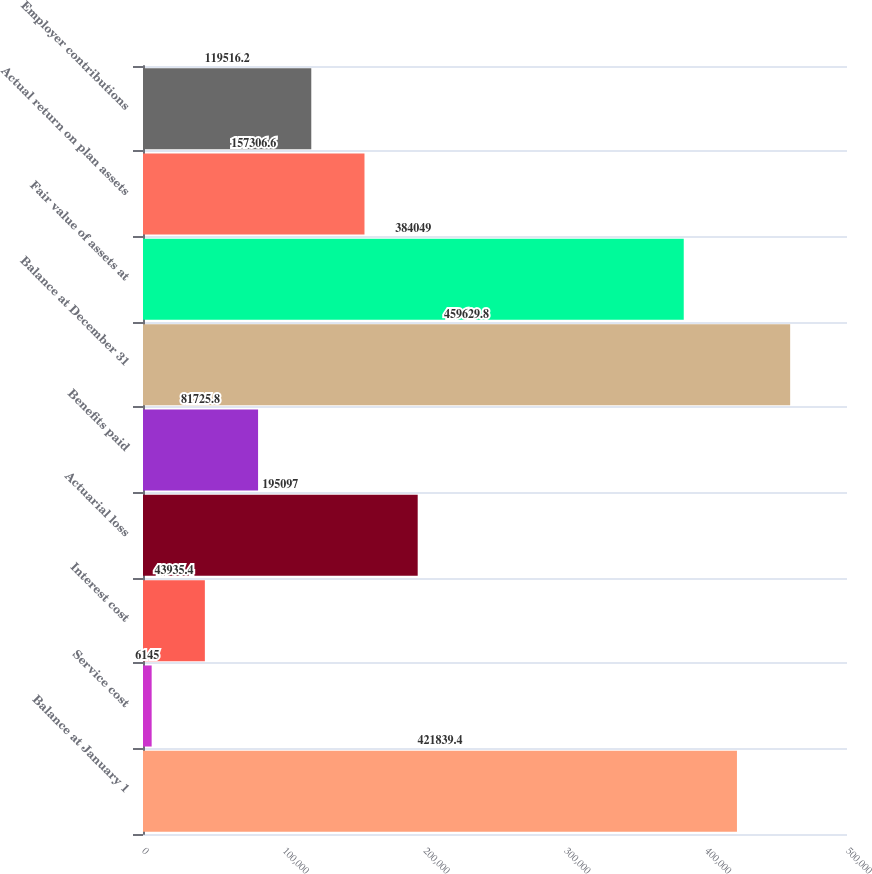Convert chart to OTSL. <chart><loc_0><loc_0><loc_500><loc_500><bar_chart><fcel>Balance at January 1<fcel>Service cost<fcel>Interest cost<fcel>Actuarial loss<fcel>Benefits paid<fcel>Balance at December 31<fcel>Fair value of assets at<fcel>Actual return on plan assets<fcel>Employer contributions<nl><fcel>421839<fcel>6145<fcel>43935.4<fcel>195097<fcel>81725.8<fcel>459630<fcel>384049<fcel>157307<fcel>119516<nl></chart> 